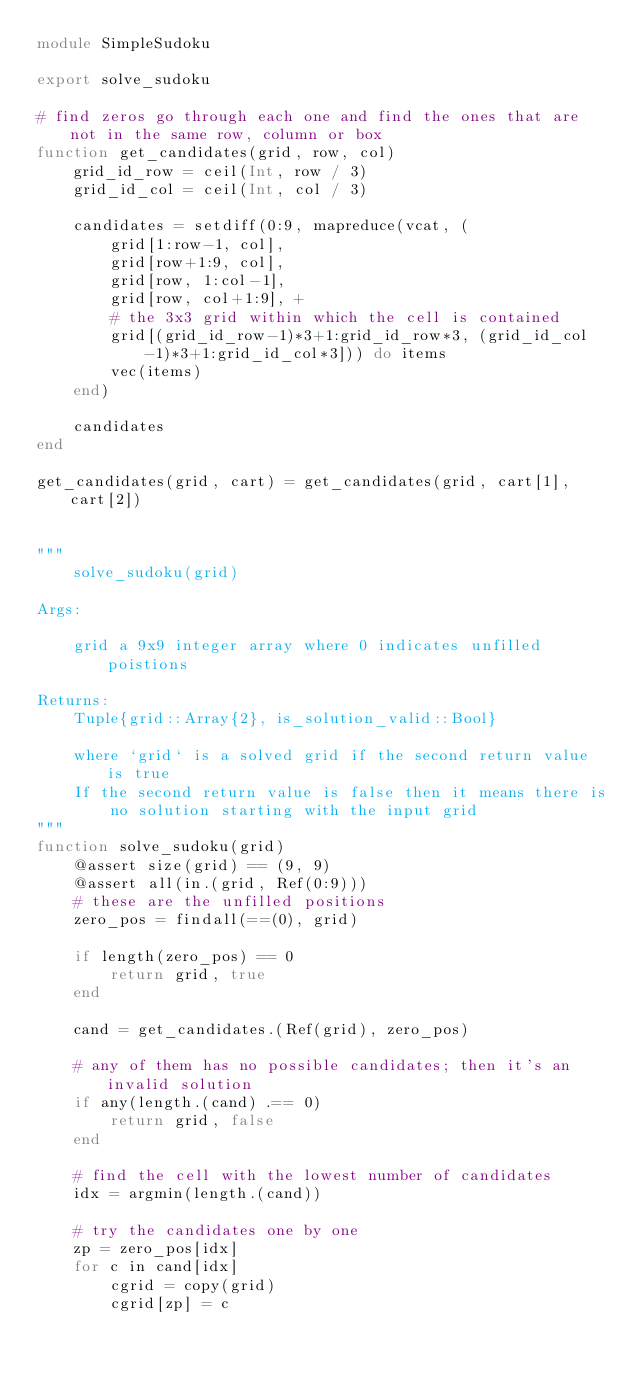Convert code to text. <code><loc_0><loc_0><loc_500><loc_500><_Julia_>module SimpleSudoku

export solve_sudoku

# find zeros go through each one and find the ones that are not in the same row, column or box
function get_candidates(grid, row, col)
    grid_id_row = ceil(Int, row / 3)
    grid_id_col = ceil(Int, col / 3)

    candidates = setdiff(0:9, mapreduce(vcat, (
        grid[1:row-1, col],
        grid[row+1:9, col],
        grid[row, 1:col-1],
        grid[row, col+1:9], +
        # the 3x3 grid within which the cell is contained
        grid[(grid_id_row-1)*3+1:grid_id_row*3, (grid_id_col-1)*3+1:grid_id_col*3])) do items
        vec(items)
    end)

    candidates
end

get_candidates(grid, cart) = get_candidates(grid, cart[1], cart[2])


"""
    solve_sudoku(grid)

Args:

    grid a 9x9 integer array where 0 indicates unfilled poistions

Returns:
    Tuple{grid::Array{2}, is_solution_valid::Bool}

    where `grid` is a solved grid if the second return value is true
    If the second return value is false then it means there is
        no solution starting with the input grid
"""
function solve_sudoku(grid)
    @assert size(grid) == (9, 9)
    @assert all(in.(grid, Ref(0:9)))
    # these are the unfilled positions
    zero_pos = findall(==(0), grid)

    if length(zero_pos) == 0
        return grid, true
    end

    cand = get_candidates.(Ref(grid), zero_pos)

    # any of them has no possible candidates; then it's an invalid solution
    if any(length.(cand) .== 0)
        return grid, false
    end

    # find the cell with the lowest number of candidates
    idx = argmin(length.(cand))

    # try the candidates one by one
    zp = zero_pos[idx]
    for c in cand[idx]
        cgrid = copy(grid)
        cgrid[zp] = c</code> 